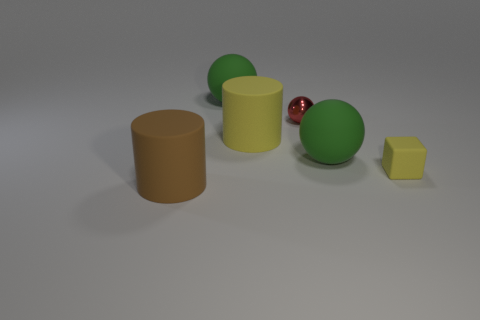Subtract all large spheres. How many spheres are left? 1 Subtract all purple blocks. How many green balls are left? 2 Add 1 red objects. How many objects exist? 7 Subtract all cylinders. How many objects are left? 4 Subtract all cyan spheres. Subtract all yellow cubes. How many spheres are left? 3 Subtract 1 yellow cylinders. How many objects are left? 5 Subtract all yellow matte cylinders. Subtract all brown cylinders. How many objects are left? 4 Add 3 yellow objects. How many yellow objects are left? 5 Add 2 brown rubber objects. How many brown rubber objects exist? 3 